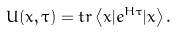<formula> <loc_0><loc_0><loc_500><loc_500>U ( x , \tau ) = t r \left \langle x | e ^ { H \tau } | x \right \rangle .</formula> 